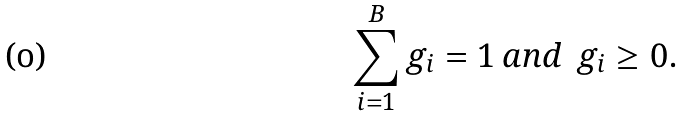<formula> <loc_0><loc_0><loc_500><loc_500>\sum _ { i = 1 } ^ { B } g _ { i } = 1 \, a n d \, \ g _ { i } \geq 0 .</formula> 